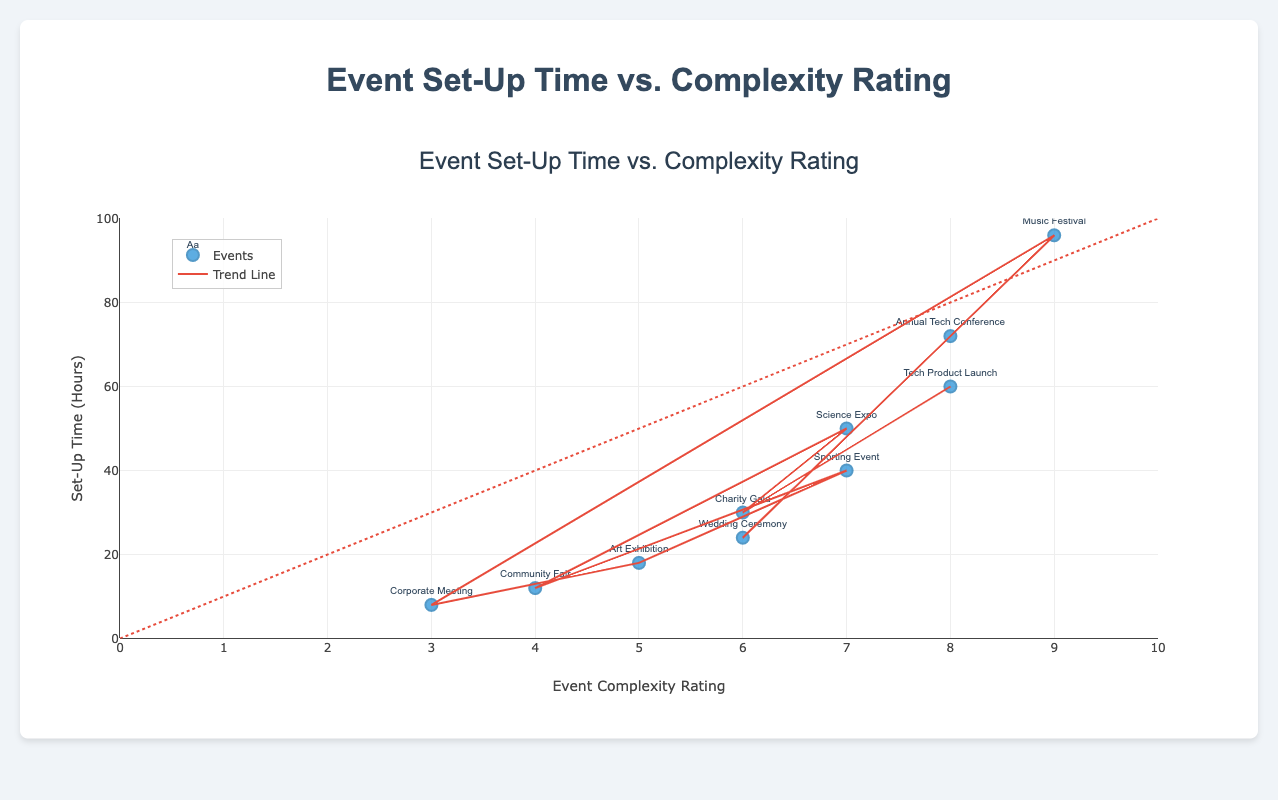What's the title of the figure? The title of the figure is positioned at the top center and it reads "Event Set-Up Time vs. Complexity Rating".
Answer: Event Set-Up Time vs. Complexity Rating What's the x-axis representing? The x-axis represents the "Event Complexity Rating", ranging from 0 to 10.
Answer: Event Complexity Rating How many data points are displayed in the scatter plot? By counting the number of markers in the scatter plot, we see there are data points for 10 different events.
Answer: 10 What is the set-up time for the event with the highest complexity rating? The event with the highest complexity rating is the "Music Festival" with a rating of 9, and its set-up time is 96 hours.
Answer: 96 hours Which event has the lowest set-up time and what is its complexity rating? The "Corporate Meeting" has the lowest set-up time of 8 hours, and its complexity rating is 3.
Answer: Corporate Meeting, 3 What is the relationship between event complexity rating and set-up time according to the trend line? The trend line suggests a positive relationship; as the event complexity rating increases, the set-up time generally increases.
Answer: Positive relationship What is the average set-up time for events with a complexity rating of 7? There are two events with a complexity rating of 7: "Sporting Event" with 40 hours and "Science Expo" with 50 hours. The average set-up time is (40 + 50) / 2 = 45 hours.
Answer: 45 hours Which event has a set-up time that deviates the most from the trend line? Comparing the scatter points to the trend line visually, the "Music Festival" (96 hours, complexity 9) deviates the most as it lies far above the trend line.
Answer: Music Festival Are there more events with complexity ratings greater than 5 or less than or equal to 5? Counting the events: Greater than 5 includes "Annual Tech Conference" (8), "Wedding Ceremony" (6), "Music Festival" (9), "Sporting Event" (7), "Science Expo" (7), "Charity Gala" (6), "Tech Product Launch" (8). Less than or equal to 5 includes "Corporate Meeting" (3), "Art Exhibition" (5), "Community Fair" (4). There are 7 events with complexity ratings greater than 5 and 3 with ratings less than or equal to 5.
Answer: More events with ratings greater than 5 What is the set-up time for an event with a complexity rating of 8, and how does it compare to the average set-up time for this rating? There are two events with a complexity rating of 8: "Annual Tech Conference" with 72 hours and "Tech Product Launch" with 60 hours. The average set-up time is (72 + 60) / 2 = 66 hours. Comparing the set-up time for either event (72 or 60) to the average, we find 72 is higher and 60 is lower.
Answer: Annual Tech Conference: 72 hours, Tech Product Launch: 60 hours, Average: 66 hours 